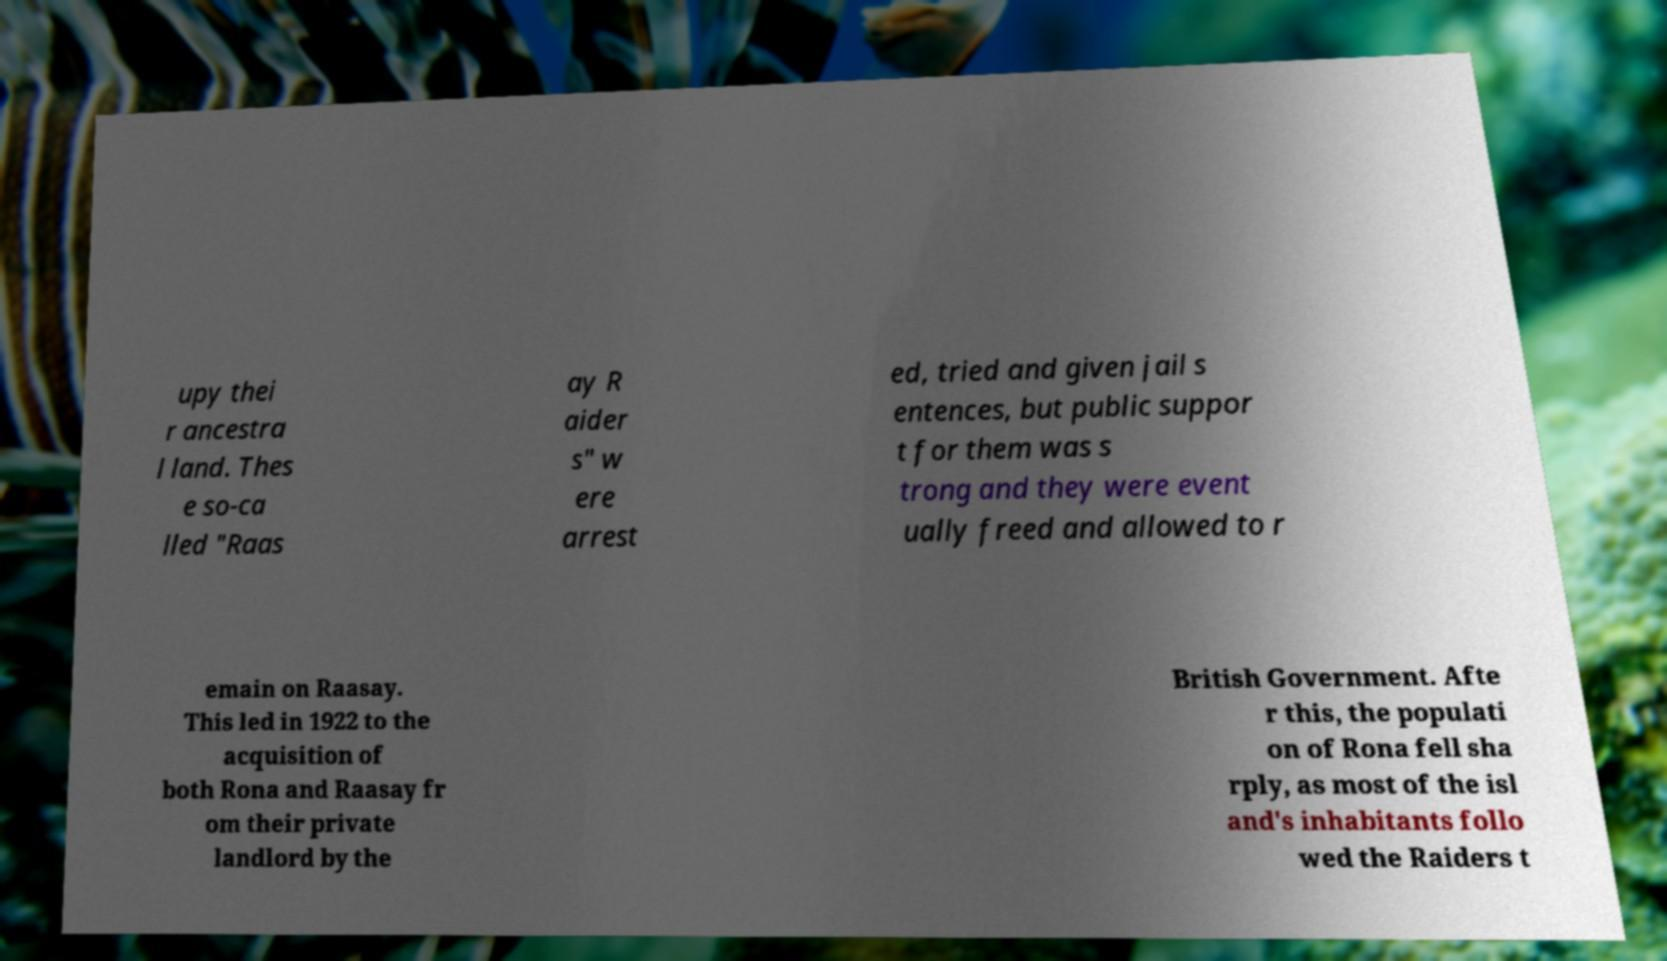Can you read and provide the text displayed in the image?This photo seems to have some interesting text. Can you extract and type it out for me? upy thei r ancestra l land. Thes e so-ca lled "Raas ay R aider s" w ere arrest ed, tried and given jail s entences, but public suppor t for them was s trong and they were event ually freed and allowed to r emain on Raasay. This led in 1922 to the acquisition of both Rona and Raasay fr om their private landlord by the British Government. Afte r this, the populati on of Rona fell sha rply, as most of the isl and's inhabitants follo wed the Raiders t 